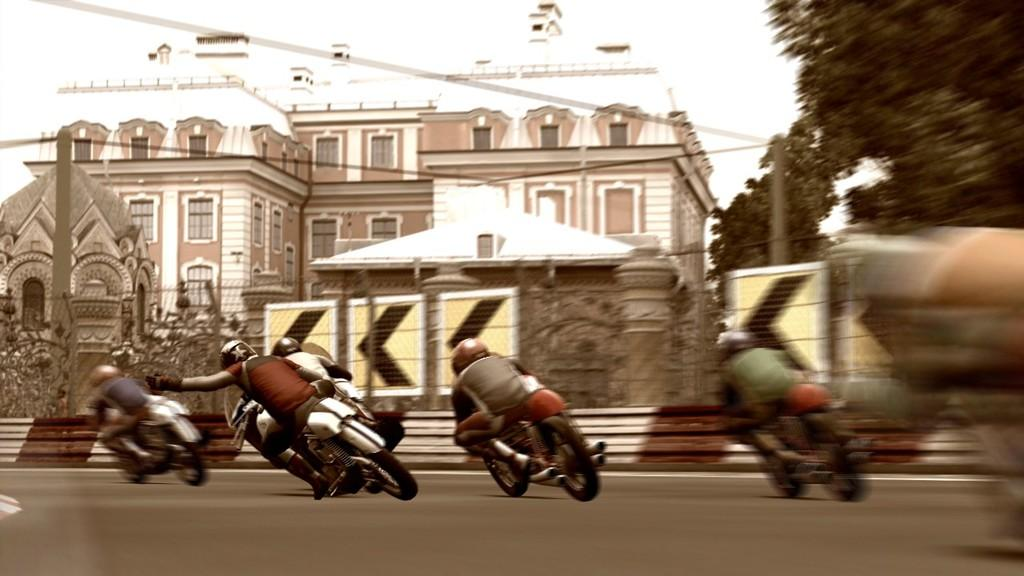What are the persons in the image doing? The persons in the image are riding a motorbike. What can be seen in the background of the image? There is a building with windows in the image, and trees are beside the building. Are there any other objects or structures visible in the image? Yes, there are sign boards in the image. What type of grain is being sorted by the insect in the image? There is no grain or insect present in the image. 